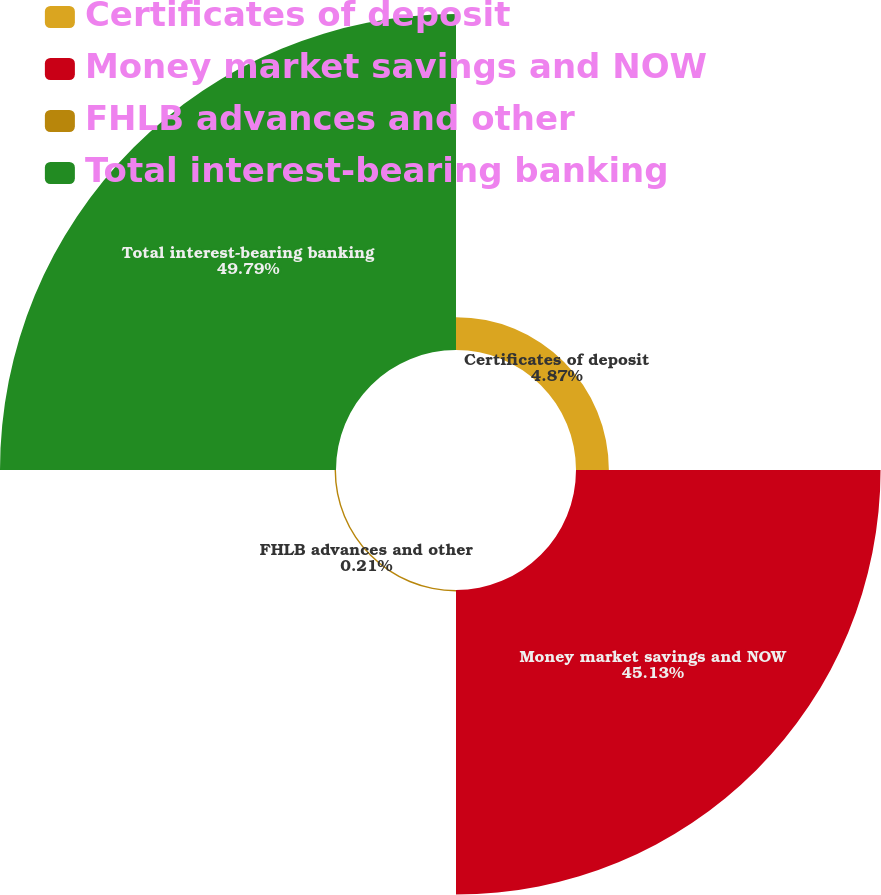Convert chart to OTSL. <chart><loc_0><loc_0><loc_500><loc_500><pie_chart><fcel>Certificates of deposit<fcel>Money market savings and NOW<fcel>FHLB advances and other<fcel>Total interest-bearing banking<nl><fcel>4.87%<fcel>45.13%<fcel>0.21%<fcel>49.79%<nl></chart> 